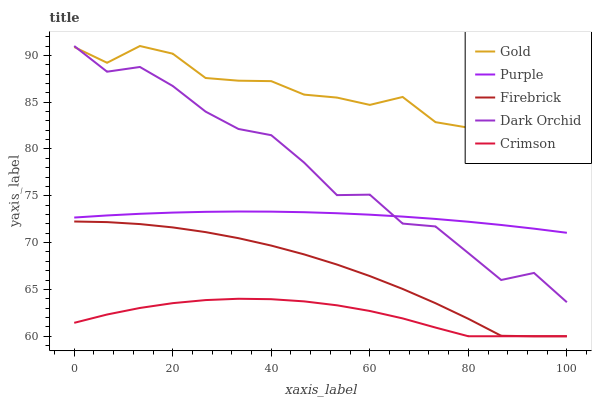Does Crimson have the minimum area under the curve?
Answer yes or no. Yes. Does Gold have the maximum area under the curve?
Answer yes or no. Yes. Does Firebrick have the minimum area under the curve?
Answer yes or no. No. Does Firebrick have the maximum area under the curve?
Answer yes or no. No. Is Purple the smoothest?
Answer yes or no. Yes. Is Dark Orchid the roughest?
Answer yes or no. Yes. Is Crimson the smoothest?
Answer yes or no. No. Is Crimson the roughest?
Answer yes or no. No. Does Crimson have the lowest value?
Answer yes or no. Yes. Does Dark Orchid have the lowest value?
Answer yes or no. No. Does Gold have the highest value?
Answer yes or no. Yes. Does Firebrick have the highest value?
Answer yes or no. No. Is Purple less than Gold?
Answer yes or no. Yes. Is Gold greater than Firebrick?
Answer yes or no. Yes. Does Dark Orchid intersect Purple?
Answer yes or no. Yes. Is Dark Orchid less than Purple?
Answer yes or no. No. Is Dark Orchid greater than Purple?
Answer yes or no. No. Does Purple intersect Gold?
Answer yes or no. No. 